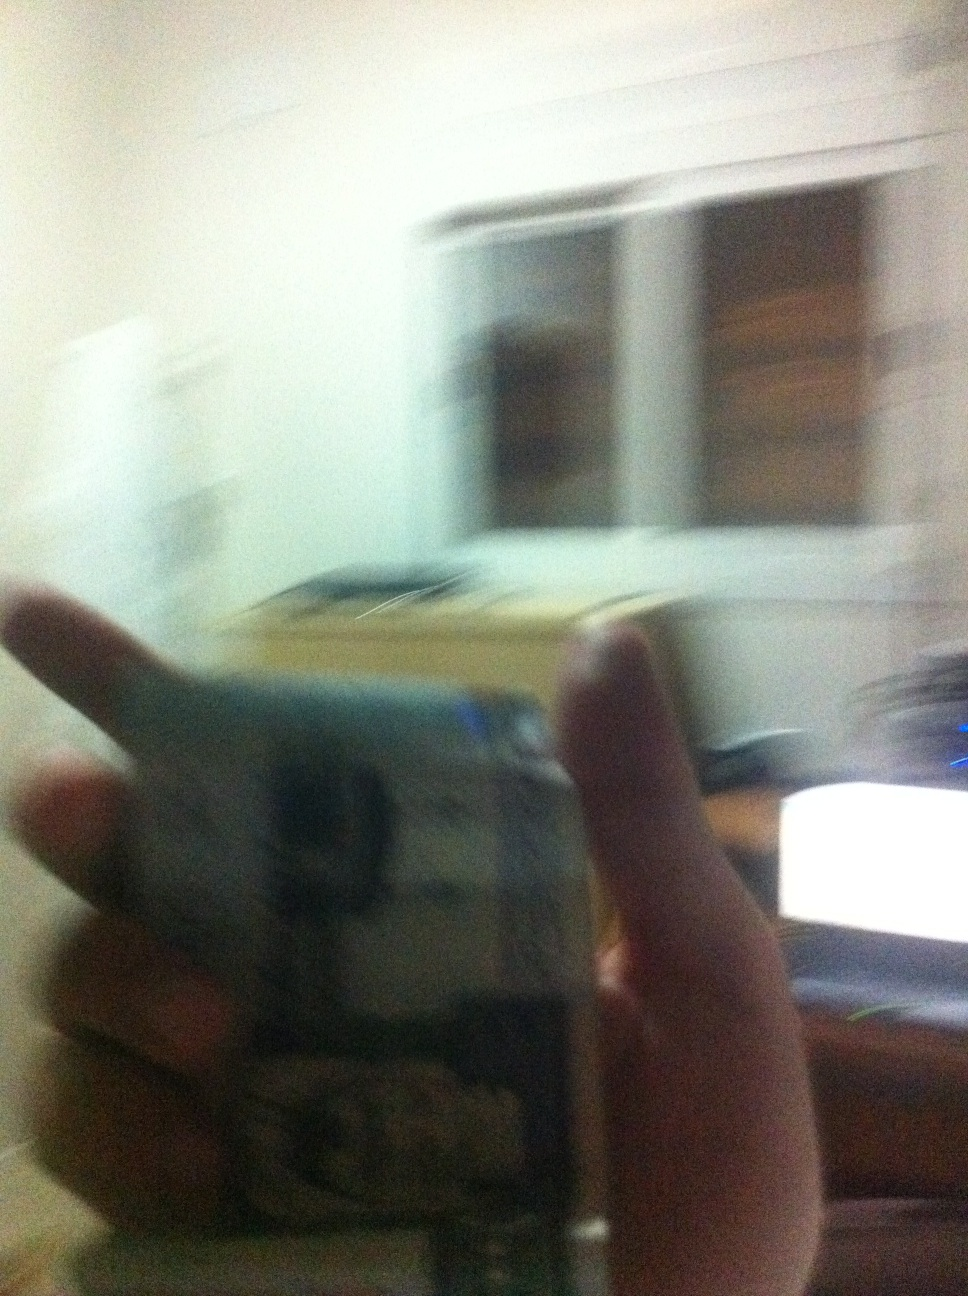What can you say about this blurry image? The image is blurry, but it appears to show someone holding currency in a room. Due to the blurriness, details about the room and the currency are indistinguishable. 